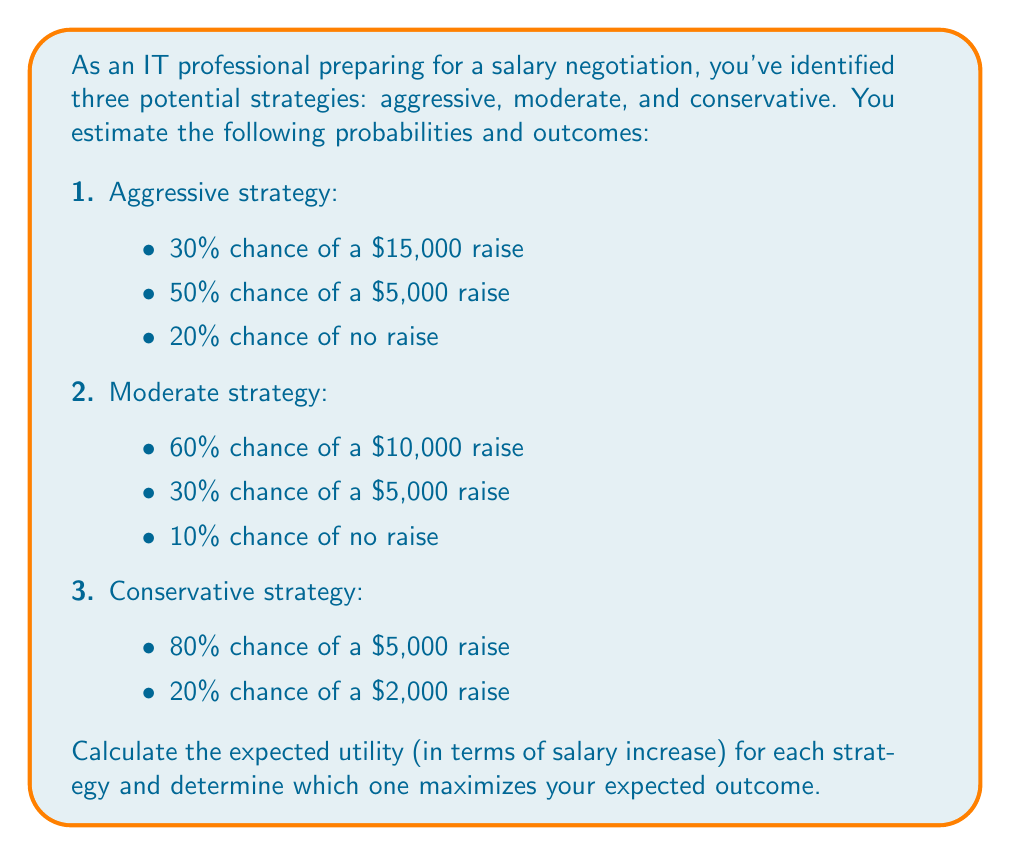Help me with this question. To solve this problem, we'll use decision trees and calculate the expected utility for each strategy. The expected utility is the sum of each possible outcome multiplied by its probability.

Let's calculate the expected utility for each strategy:

1. Aggressive strategy:
   $$E(\text{Aggressive}) = 0.30 \times \$15,000 + 0.50 \times \$5,000 + 0.20 \times \$0$$
   $$E(\text{Aggressive}) = \$4,500 + \$2,500 + \$0 = \$7,000$$

2. Moderate strategy:
   $$E(\text{Moderate}) = 0.60 \times \$10,000 + 0.30 \times \$5,000 + 0.10 \times \$0$$
   $$E(\text{Moderate}) = \$6,000 + \$1,500 + \$0 = \$7,500$$

3. Conservative strategy:
   $$E(\text{Conservative}) = 0.80 \times \$5,000 + 0.20 \times \$2,000$$
   $$E(\text{Conservative}) = \$4,000 + \$400 = \$4,400$$

To visualize this, we can create a simple decision tree:

[asy]
import geometry;

size(200,150);

pair A = (0,0);
pair B1 = (100,50);
pair B2 = (100,0);
pair B3 = (100,-50);

draw(A--B1);
draw(A--B2);
draw(A--B3);

label("Start", A, W);
label("Aggressive $7,000", B1, E);
label("Moderate $7,500", B2, E);
label("Conservative $4,400", B3, E);
[/asy]

Comparing the expected utilities:
1. Aggressive strategy: $7,000
2. Moderate strategy: $7,500
3. Conservative strategy: $4,400

The strategy that maximizes the expected outcome is the moderate strategy, with an expected salary increase of $7,500.
Answer: The moderate strategy maximizes the expected utility with an expected salary increase of $7,500. 